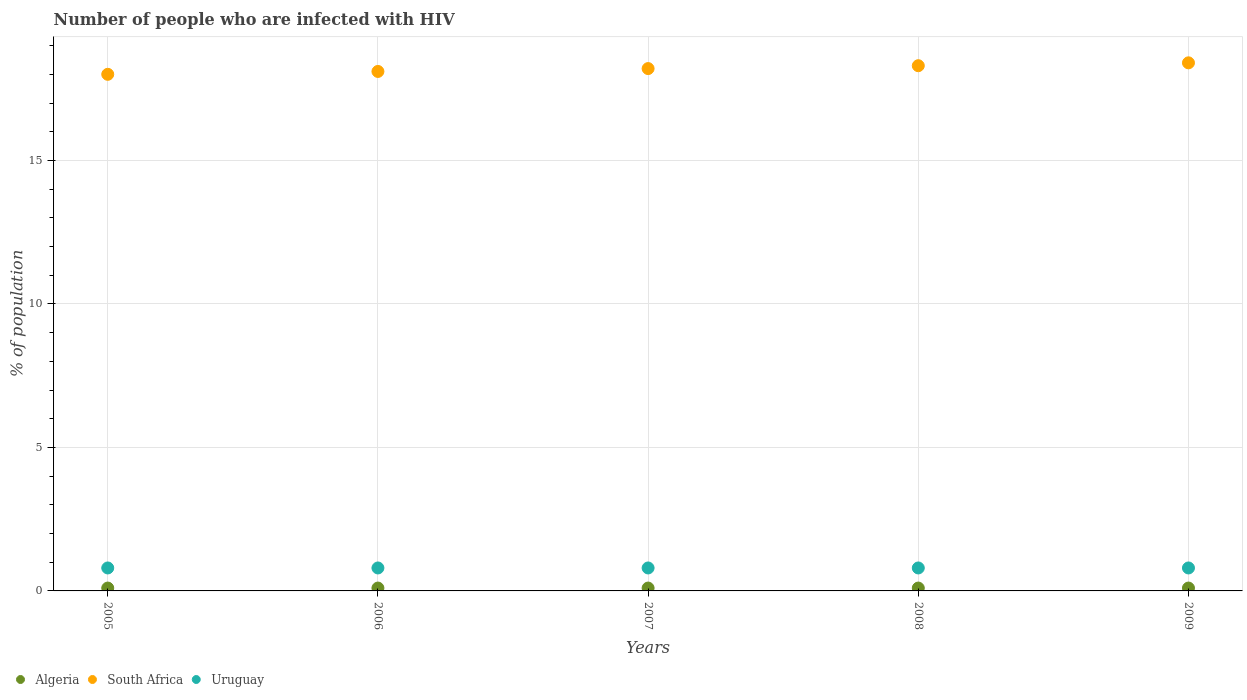How many different coloured dotlines are there?
Make the answer very short. 3. Is the number of dotlines equal to the number of legend labels?
Ensure brevity in your answer.  Yes. What is the percentage of HIV infected population in in Uruguay in 2006?
Your response must be concise. 0.8. In which year was the percentage of HIV infected population in in Algeria maximum?
Your answer should be very brief. 2005. What is the difference between the percentage of HIV infected population in in South Africa in 2005 and that in 2008?
Offer a terse response. -0.3. What is the difference between the percentage of HIV infected population in in Uruguay in 2005 and the percentage of HIV infected population in in South Africa in 2008?
Your answer should be compact. -17.5. In the year 2009, what is the difference between the percentage of HIV infected population in in South Africa and percentage of HIV infected population in in Uruguay?
Give a very brief answer. 17.6. In how many years, is the percentage of HIV infected population in in Algeria greater than 7 %?
Provide a succinct answer. 0. What is the ratio of the percentage of HIV infected population in in Algeria in 2005 to that in 2007?
Your response must be concise. 1. Is the difference between the percentage of HIV infected population in in South Africa in 2005 and 2007 greater than the difference between the percentage of HIV infected population in in Uruguay in 2005 and 2007?
Keep it short and to the point. No. What is the difference between the highest and the second highest percentage of HIV infected population in in Algeria?
Offer a terse response. 0. In how many years, is the percentage of HIV infected population in in Uruguay greater than the average percentage of HIV infected population in in Uruguay taken over all years?
Keep it short and to the point. 0. Is the sum of the percentage of HIV infected population in in South Africa in 2006 and 2008 greater than the maximum percentage of HIV infected population in in Uruguay across all years?
Offer a terse response. Yes. How many dotlines are there?
Provide a succinct answer. 3. How are the legend labels stacked?
Offer a terse response. Horizontal. What is the title of the graph?
Make the answer very short. Number of people who are infected with HIV. What is the label or title of the Y-axis?
Offer a terse response. % of population. What is the % of population in Algeria in 2005?
Ensure brevity in your answer.  0.1. What is the % of population of Algeria in 2006?
Make the answer very short. 0.1. What is the % of population of South Africa in 2006?
Provide a short and direct response. 18.1. What is the % of population of Uruguay in 2006?
Your answer should be very brief. 0.8. What is the % of population in Algeria in 2007?
Offer a very short reply. 0.1. What is the % of population in South Africa in 2007?
Your response must be concise. 18.2. What is the % of population of Uruguay in 2007?
Provide a succinct answer. 0.8. What is the % of population in South Africa in 2008?
Give a very brief answer. 18.3. What is the % of population of Algeria in 2009?
Your response must be concise. 0.1. What is the % of population in South Africa in 2009?
Make the answer very short. 18.4. What is the % of population of Uruguay in 2009?
Give a very brief answer. 0.8. Across all years, what is the maximum % of population in Algeria?
Your response must be concise. 0.1. Across all years, what is the maximum % of population of South Africa?
Your answer should be compact. 18.4. Across all years, what is the maximum % of population in Uruguay?
Keep it short and to the point. 0.8. Across all years, what is the minimum % of population of Algeria?
Your answer should be very brief. 0.1. Across all years, what is the minimum % of population in South Africa?
Your answer should be very brief. 18. What is the total % of population of Algeria in the graph?
Provide a succinct answer. 0.5. What is the total % of population in South Africa in the graph?
Keep it short and to the point. 91. What is the difference between the % of population in Algeria in 2005 and that in 2006?
Ensure brevity in your answer.  0. What is the difference between the % of population in South Africa in 2005 and that in 2006?
Your response must be concise. -0.1. What is the difference between the % of population in Uruguay in 2005 and that in 2006?
Make the answer very short. 0. What is the difference between the % of population of Algeria in 2005 and that in 2007?
Your answer should be compact. 0. What is the difference between the % of population of Uruguay in 2005 and that in 2007?
Provide a succinct answer. 0. What is the difference between the % of population in Algeria in 2005 and that in 2009?
Provide a succinct answer. 0. What is the difference between the % of population of Uruguay in 2005 and that in 2009?
Give a very brief answer. 0. What is the difference between the % of population in Algeria in 2006 and that in 2007?
Your response must be concise. 0. What is the difference between the % of population in Uruguay in 2006 and that in 2007?
Provide a succinct answer. 0. What is the difference between the % of population of South Africa in 2006 and that in 2008?
Give a very brief answer. -0.2. What is the difference between the % of population in Algeria in 2006 and that in 2009?
Provide a succinct answer. 0. What is the difference between the % of population of Uruguay in 2006 and that in 2009?
Provide a succinct answer. 0. What is the difference between the % of population of Algeria in 2007 and that in 2008?
Your response must be concise. 0. What is the difference between the % of population of South Africa in 2007 and that in 2008?
Ensure brevity in your answer.  -0.1. What is the difference between the % of population of South Africa in 2007 and that in 2009?
Ensure brevity in your answer.  -0.2. What is the difference between the % of population of South Africa in 2008 and that in 2009?
Your response must be concise. -0.1. What is the difference between the % of population in South Africa in 2005 and the % of population in Uruguay in 2006?
Provide a short and direct response. 17.2. What is the difference between the % of population of Algeria in 2005 and the % of population of South Africa in 2007?
Offer a terse response. -18.1. What is the difference between the % of population of Algeria in 2005 and the % of population of Uruguay in 2007?
Provide a short and direct response. -0.7. What is the difference between the % of population in Algeria in 2005 and the % of population in South Africa in 2008?
Provide a succinct answer. -18.2. What is the difference between the % of population in Algeria in 2005 and the % of population in South Africa in 2009?
Keep it short and to the point. -18.3. What is the difference between the % of population of Algeria in 2005 and the % of population of Uruguay in 2009?
Offer a very short reply. -0.7. What is the difference between the % of population in South Africa in 2005 and the % of population in Uruguay in 2009?
Keep it short and to the point. 17.2. What is the difference between the % of population of Algeria in 2006 and the % of population of South Africa in 2007?
Provide a succinct answer. -18.1. What is the difference between the % of population of Algeria in 2006 and the % of population of Uruguay in 2007?
Keep it short and to the point. -0.7. What is the difference between the % of population in South Africa in 2006 and the % of population in Uruguay in 2007?
Your answer should be compact. 17.3. What is the difference between the % of population of Algeria in 2006 and the % of population of South Africa in 2008?
Offer a very short reply. -18.2. What is the difference between the % of population in Algeria in 2006 and the % of population in Uruguay in 2008?
Make the answer very short. -0.7. What is the difference between the % of population of Algeria in 2006 and the % of population of South Africa in 2009?
Offer a terse response. -18.3. What is the difference between the % of population in South Africa in 2006 and the % of population in Uruguay in 2009?
Offer a very short reply. 17.3. What is the difference between the % of population of Algeria in 2007 and the % of population of South Africa in 2008?
Give a very brief answer. -18.2. What is the difference between the % of population of Algeria in 2007 and the % of population of Uruguay in 2008?
Offer a very short reply. -0.7. What is the difference between the % of population in South Africa in 2007 and the % of population in Uruguay in 2008?
Your answer should be compact. 17.4. What is the difference between the % of population of Algeria in 2007 and the % of population of South Africa in 2009?
Offer a terse response. -18.3. What is the difference between the % of population of Algeria in 2007 and the % of population of Uruguay in 2009?
Your answer should be very brief. -0.7. What is the difference between the % of population of Algeria in 2008 and the % of population of South Africa in 2009?
Your response must be concise. -18.3. What is the difference between the % of population of South Africa in 2008 and the % of population of Uruguay in 2009?
Offer a terse response. 17.5. What is the average % of population of Algeria per year?
Your answer should be very brief. 0.1. What is the average % of population of South Africa per year?
Your answer should be compact. 18.2. What is the average % of population in Uruguay per year?
Ensure brevity in your answer.  0.8. In the year 2005, what is the difference between the % of population in Algeria and % of population in South Africa?
Keep it short and to the point. -17.9. In the year 2005, what is the difference between the % of population of Algeria and % of population of Uruguay?
Your answer should be compact. -0.7. In the year 2006, what is the difference between the % of population in South Africa and % of population in Uruguay?
Your answer should be very brief. 17.3. In the year 2007, what is the difference between the % of population in Algeria and % of population in South Africa?
Provide a succinct answer. -18.1. In the year 2007, what is the difference between the % of population of Algeria and % of population of Uruguay?
Your answer should be very brief. -0.7. In the year 2007, what is the difference between the % of population in South Africa and % of population in Uruguay?
Ensure brevity in your answer.  17.4. In the year 2008, what is the difference between the % of population in Algeria and % of population in South Africa?
Your answer should be very brief. -18.2. In the year 2008, what is the difference between the % of population of Algeria and % of population of Uruguay?
Offer a very short reply. -0.7. In the year 2008, what is the difference between the % of population in South Africa and % of population in Uruguay?
Keep it short and to the point. 17.5. In the year 2009, what is the difference between the % of population in Algeria and % of population in South Africa?
Make the answer very short. -18.3. What is the ratio of the % of population in South Africa in 2005 to that in 2006?
Ensure brevity in your answer.  0.99. What is the ratio of the % of population in Algeria in 2005 to that in 2007?
Provide a short and direct response. 1. What is the ratio of the % of population in South Africa in 2005 to that in 2007?
Your answer should be very brief. 0.99. What is the ratio of the % of population of South Africa in 2005 to that in 2008?
Offer a terse response. 0.98. What is the ratio of the % of population of Uruguay in 2005 to that in 2008?
Ensure brevity in your answer.  1. What is the ratio of the % of population in Algeria in 2005 to that in 2009?
Keep it short and to the point. 1. What is the ratio of the % of population of South Africa in 2005 to that in 2009?
Make the answer very short. 0.98. What is the ratio of the % of population in Uruguay in 2005 to that in 2009?
Offer a terse response. 1. What is the ratio of the % of population in South Africa in 2006 to that in 2007?
Your answer should be very brief. 0.99. What is the ratio of the % of population in South Africa in 2006 to that in 2009?
Your response must be concise. 0.98. What is the ratio of the % of population in South Africa in 2007 to that in 2009?
Provide a succinct answer. 0.99. What is the ratio of the % of population of Uruguay in 2007 to that in 2009?
Keep it short and to the point. 1. What is the ratio of the % of population in South Africa in 2008 to that in 2009?
Ensure brevity in your answer.  0.99. What is the difference between the highest and the second highest % of population in Algeria?
Provide a succinct answer. 0. What is the difference between the highest and the second highest % of population in Uruguay?
Give a very brief answer. 0. What is the difference between the highest and the lowest % of population in South Africa?
Ensure brevity in your answer.  0.4. What is the difference between the highest and the lowest % of population of Uruguay?
Your answer should be very brief. 0. 